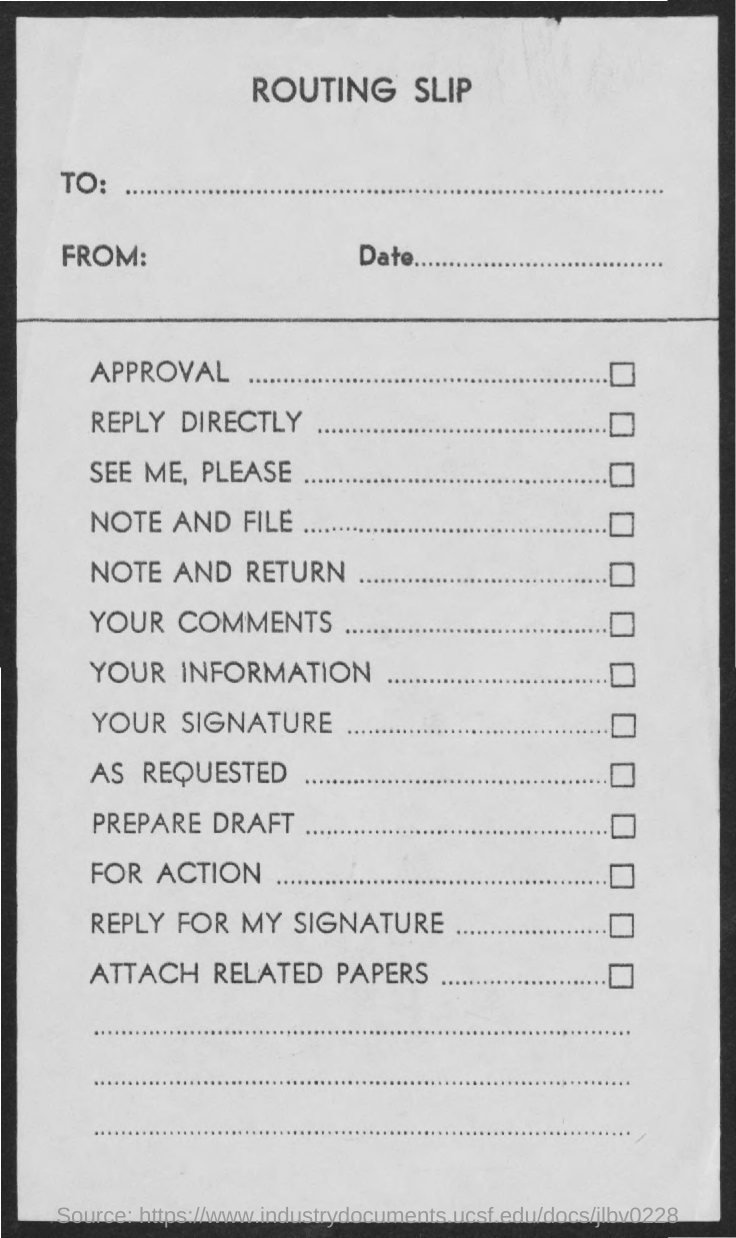Give some essential details in this illustration. The document is called a Routing Slip. 